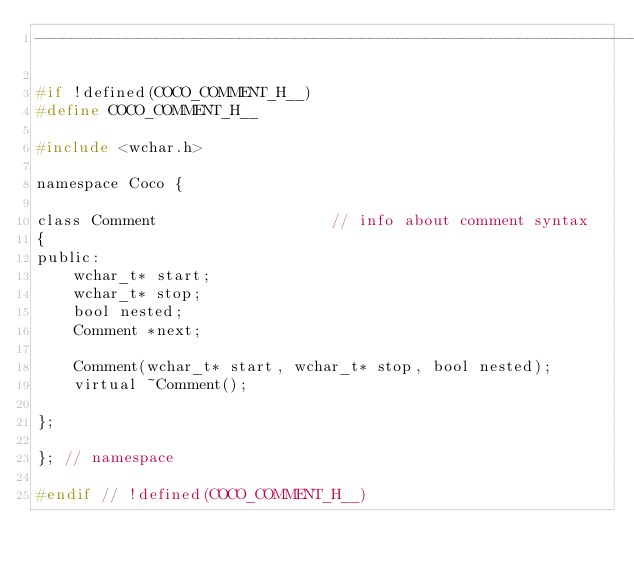Convert code to text. <code><loc_0><loc_0><loc_500><loc_500><_C_>-------------------------------------------------------------------------*/

#if !defined(COCO_COMMENT_H__)
#define COCO_COMMENT_H__

#include <wchar.h>

namespace Coco {

class Comment  					// info about comment syntax
{
public:
	wchar_t* start;
	wchar_t* stop;
	bool nested;
	Comment *next;

	Comment(wchar_t* start, wchar_t* stop, bool nested);
	virtual ~Comment();

};

}; // namespace

#endif // !defined(COCO_COMMENT_H__)
</code> 